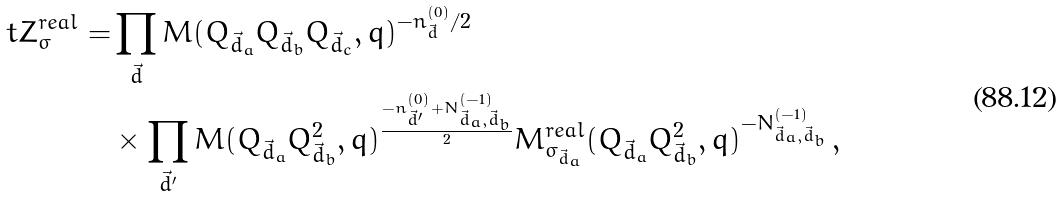<formula> <loc_0><loc_0><loc_500><loc_500>\ t Z ^ { r e a l } _ { \sigma } = & \prod _ { \vec { d } } M ( Q _ { \vec { d } _ { a } } Q _ { \vec { d } _ { b } } Q _ { \vec { d } _ { c } } , q ) ^ { - n ^ { ( 0 ) } _ { \vec { d } } / 2 } \\ & \times \prod _ { \vec { d } ^ { \prime } } M ( Q _ { \vec { d } _ { a } } Q ^ { 2 } _ { \vec { d } _ { b } } , q ) ^ { \frac { - n ^ { ( 0 ) } _ { \vec { d } ^ { \prime } } + N ^ { ( - 1 ) } _ { \vec { d } _ { a } , \vec { d } _ { b } } } { 2 } } M ^ { r e a l } _ { \sigma _ { \vec { d } _ { a } } } ( Q _ { \vec { d } _ { a } } Q ^ { 2 } _ { \vec { d } _ { b } } , q ) ^ { - N ^ { ( - 1 ) } _ { \vec { d } _ { a } , \vec { d } _ { b } } } \, ,</formula> 